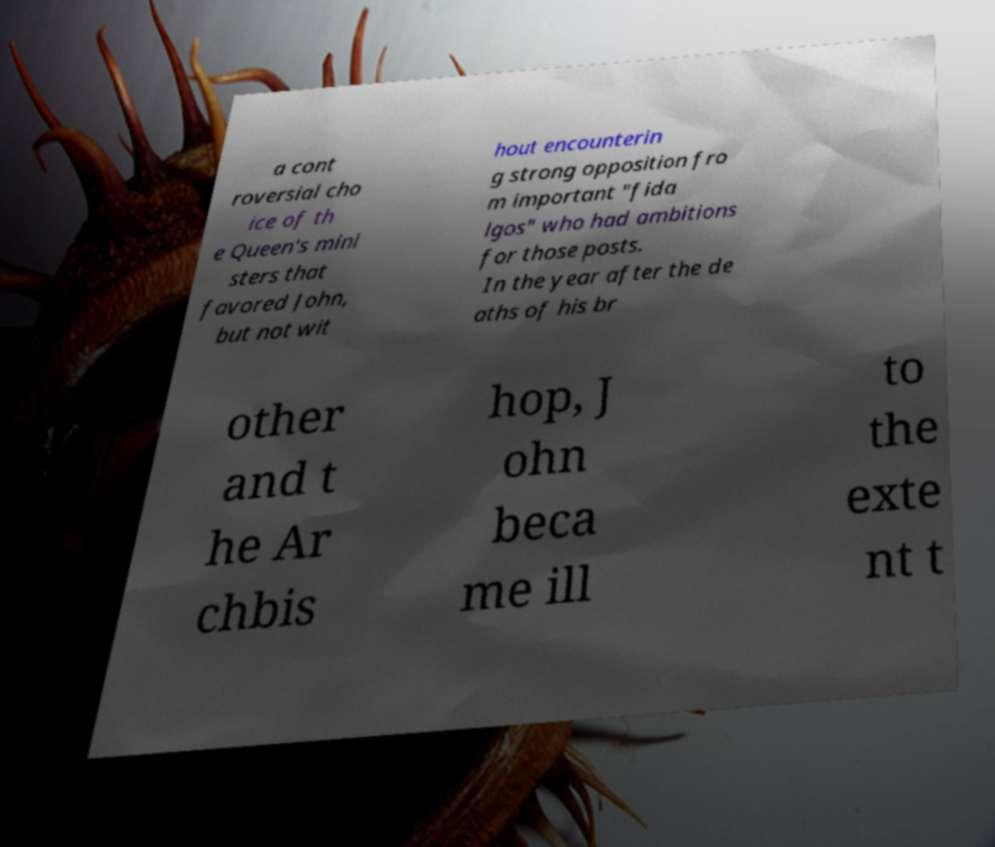For documentation purposes, I need the text within this image transcribed. Could you provide that? a cont roversial cho ice of th e Queen's mini sters that favored John, but not wit hout encounterin g strong opposition fro m important "fida lgos" who had ambitions for those posts. In the year after the de aths of his br other and t he Ar chbis hop, J ohn beca me ill to the exte nt t 